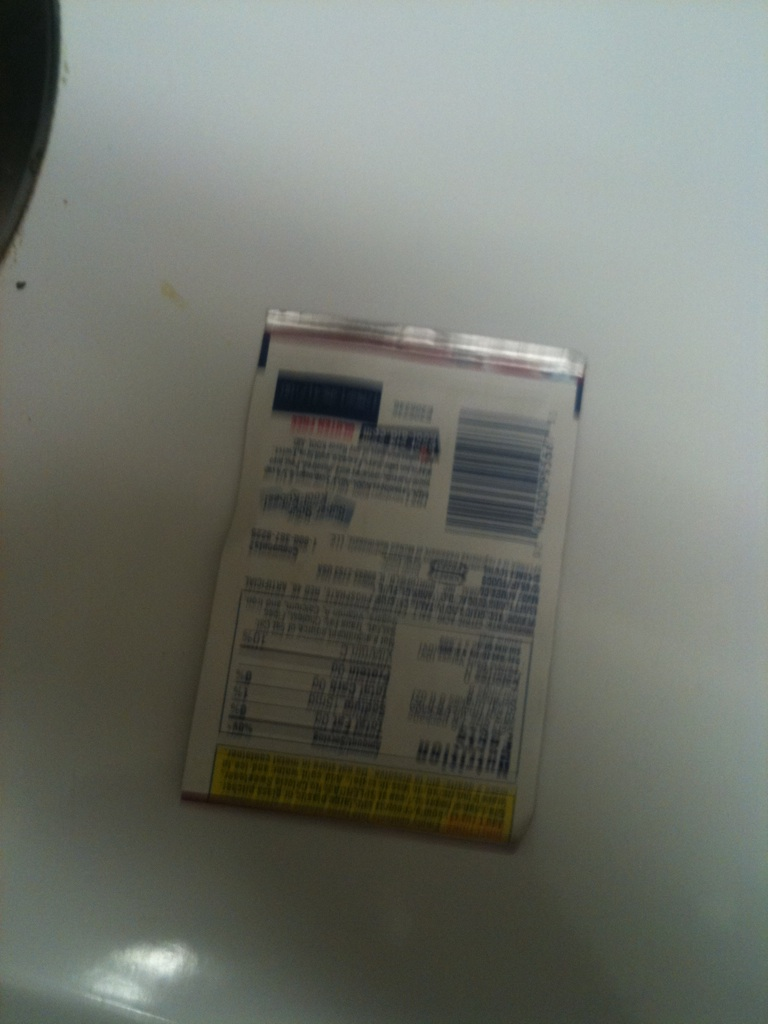Imagine if this package could talk. What stories would it tell about its journey from the factory to the kitchen? If this package could talk, it might tell tales of its creation in a bustling factory, filled with the aroma of fresh ingredients being processed and packaged. It would recount the excitement of being loaded onto delivery trucks, traveling across cities and towns, and finally arriving at a local store shelf. It would recall the eager shopper who picked it up, ensuring it was just the right addition to their next culinary adventure. Finally, it would express the joy of being used in a kitchen, contributing to the creation of delicious dishes and heartfelt meals. 